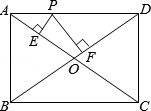Let's assume the rectangle ABCD is on a coordinate plane with A at the origin, how would you find the coordinates of point P if it is known that PF is 1.2? With A at the origin (0,0) and AB along the y-axis and AD along the x-axis, D would be at (4,0), B at (0,3), and C at (4,3). Using similar triangles, we have PF/PD = OF/OD, giving us PF=OF. Since OF is half of diagonal BD, which is 5, OF = PF = 1.2. Triangle OFD is a right triangle with OF known, we can find FD as the square root of (OD^2 - OF^2) = (2.5^2 - 1.2^2) = 2.1. With FD found, we know that P lies 2.1 units from D along AD. Therefore, the coordinates of P would be (4 - 2.1, 0) or approximately (1.9, 0). 